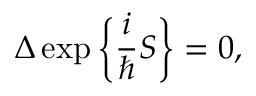<formula> <loc_0><loc_0><loc_500><loc_500>\Delta \exp \left \{ \frac { i } { } S \right \} = 0 ,</formula> 